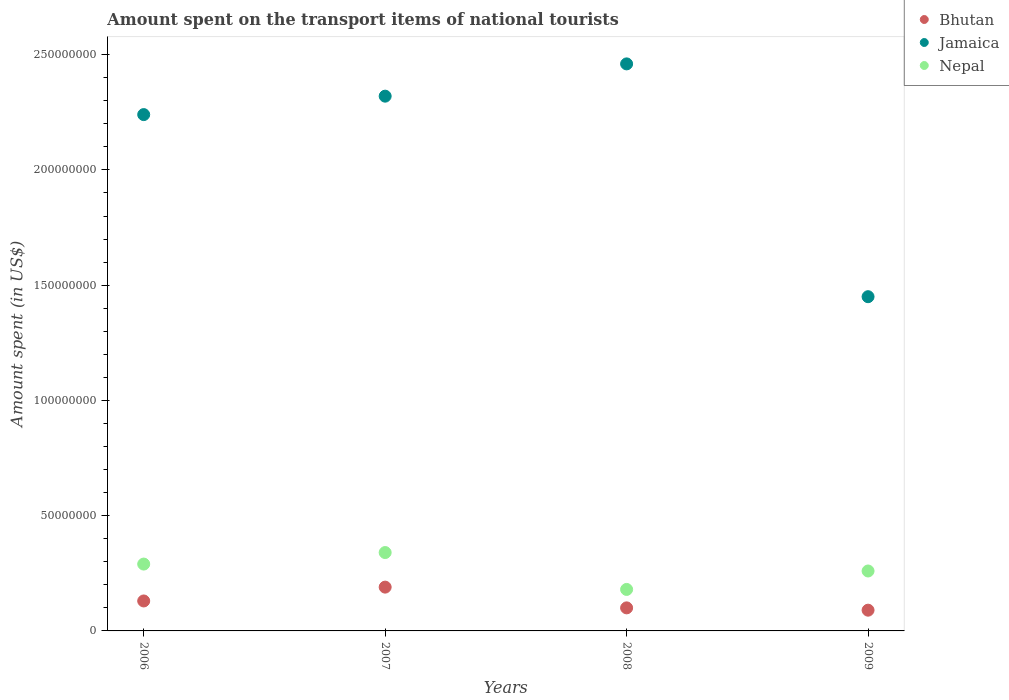How many different coloured dotlines are there?
Your answer should be compact. 3. What is the amount spent on the transport items of national tourists in Bhutan in 2006?
Provide a short and direct response. 1.30e+07. Across all years, what is the maximum amount spent on the transport items of national tourists in Nepal?
Provide a short and direct response. 3.40e+07. Across all years, what is the minimum amount spent on the transport items of national tourists in Jamaica?
Keep it short and to the point. 1.45e+08. In which year was the amount spent on the transport items of national tourists in Jamaica minimum?
Your answer should be very brief. 2009. What is the total amount spent on the transport items of national tourists in Bhutan in the graph?
Provide a succinct answer. 5.10e+07. What is the difference between the amount spent on the transport items of national tourists in Bhutan in 2007 and the amount spent on the transport items of national tourists in Jamaica in 2008?
Keep it short and to the point. -2.27e+08. What is the average amount spent on the transport items of national tourists in Nepal per year?
Ensure brevity in your answer.  2.68e+07. In the year 2007, what is the difference between the amount spent on the transport items of national tourists in Bhutan and amount spent on the transport items of national tourists in Nepal?
Give a very brief answer. -1.50e+07. Is the amount spent on the transport items of national tourists in Nepal in 2008 less than that in 2009?
Provide a short and direct response. Yes. Is the difference between the amount spent on the transport items of national tourists in Bhutan in 2008 and 2009 greater than the difference between the amount spent on the transport items of national tourists in Nepal in 2008 and 2009?
Make the answer very short. Yes. What is the difference between the highest and the second highest amount spent on the transport items of national tourists in Bhutan?
Provide a succinct answer. 6.00e+06. What is the difference between the highest and the lowest amount spent on the transport items of national tourists in Jamaica?
Your response must be concise. 1.01e+08. Does the amount spent on the transport items of national tourists in Jamaica monotonically increase over the years?
Your response must be concise. No. Is the amount spent on the transport items of national tourists in Bhutan strictly less than the amount spent on the transport items of national tourists in Jamaica over the years?
Your answer should be very brief. Yes. What is the difference between two consecutive major ticks on the Y-axis?
Ensure brevity in your answer.  5.00e+07. Are the values on the major ticks of Y-axis written in scientific E-notation?
Ensure brevity in your answer.  No. How many legend labels are there?
Make the answer very short. 3. How are the legend labels stacked?
Keep it short and to the point. Vertical. What is the title of the graph?
Your response must be concise. Amount spent on the transport items of national tourists. What is the label or title of the X-axis?
Provide a short and direct response. Years. What is the label or title of the Y-axis?
Your answer should be compact. Amount spent (in US$). What is the Amount spent (in US$) in Bhutan in 2006?
Ensure brevity in your answer.  1.30e+07. What is the Amount spent (in US$) of Jamaica in 2006?
Offer a terse response. 2.24e+08. What is the Amount spent (in US$) of Nepal in 2006?
Ensure brevity in your answer.  2.90e+07. What is the Amount spent (in US$) in Bhutan in 2007?
Your answer should be very brief. 1.90e+07. What is the Amount spent (in US$) in Jamaica in 2007?
Provide a succinct answer. 2.32e+08. What is the Amount spent (in US$) of Nepal in 2007?
Ensure brevity in your answer.  3.40e+07. What is the Amount spent (in US$) in Bhutan in 2008?
Keep it short and to the point. 1.00e+07. What is the Amount spent (in US$) in Jamaica in 2008?
Offer a very short reply. 2.46e+08. What is the Amount spent (in US$) of Nepal in 2008?
Offer a terse response. 1.80e+07. What is the Amount spent (in US$) in Bhutan in 2009?
Make the answer very short. 9.00e+06. What is the Amount spent (in US$) in Jamaica in 2009?
Keep it short and to the point. 1.45e+08. What is the Amount spent (in US$) of Nepal in 2009?
Give a very brief answer. 2.60e+07. Across all years, what is the maximum Amount spent (in US$) of Bhutan?
Your answer should be compact. 1.90e+07. Across all years, what is the maximum Amount spent (in US$) in Jamaica?
Provide a short and direct response. 2.46e+08. Across all years, what is the maximum Amount spent (in US$) of Nepal?
Give a very brief answer. 3.40e+07. Across all years, what is the minimum Amount spent (in US$) of Bhutan?
Provide a short and direct response. 9.00e+06. Across all years, what is the minimum Amount spent (in US$) of Jamaica?
Keep it short and to the point. 1.45e+08. Across all years, what is the minimum Amount spent (in US$) in Nepal?
Provide a succinct answer. 1.80e+07. What is the total Amount spent (in US$) in Bhutan in the graph?
Give a very brief answer. 5.10e+07. What is the total Amount spent (in US$) of Jamaica in the graph?
Give a very brief answer. 8.47e+08. What is the total Amount spent (in US$) of Nepal in the graph?
Offer a terse response. 1.07e+08. What is the difference between the Amount spent (in US$) in Bhutan in 2006 and that in 2007?
Offer a very short reply. -6.00e+06. What is the difference between the Amount spent (in US$) in Jamaica in 2006 and that in 2007?
Provide a succinct answer. -8.00e+06. What is the difference between the Amount spent (in US$) in Nepal in 2006 and that in 2007?
Provide a short and direct response. -5.00e+06. What is the difference between the Amount spent (in US$) in Jamaica in 2006 and that in 2008?
Your answer should be compact. -2.20e+07. What is the difference between the Amount spent (in US$) in Nepal in 2006 and that in 2008?
Offer a terse response. 1.10e+07. What is the difference between the Amount spent (in US$) in Jamaica in 2006 and that in 2009?
Your answer should be very brief. 7.90e+07. What is the difference between the Amount spent (in US$) in Bhutan in 2007 and that in 2008?
Your answer should be compact. 9.00e+06. What is the difference between the Amount spent (in US$) in Jamaica in 2007 and that in 2008?
Keep it short and to the point. -1.40e+07. What is the difference between the Amount spent (in US$) of Nepal in 2007 and that in 2008?
Offer a terse response. 1.60e+07. What is the difference between the Amount spent (in US$) of Jamaica in 2007 and that in 2009?
Your answer should be very brief. 8.70e+07. What is the difference between the Amount spent (in US$) of Jamaica in 2008 and that in 2009?
Ensure brevity in your answer.  1.01e+08. What is the difference between the Amount spent (in US$) of Nepal in 2008 and that in 2009?
Make the answer very short. -8.00e+06. What is the difference between the Amount spent (in US$) in Bhutan in 2006 and the Amount spent (in US$) in Jamaica in 2007?
Offer a terse response. -2.19e+08. What is the difference between the Amount spent (in US$) in Bhutan in 2006 and the Amount spent (in US$) in Nepal in 2007?
Provide a short and direct response. -2.10e+07. What is the difference between the Amount spent (in US$) of Jamaica in 2006 and the Amount spent (in US$) of Nepal in 2007?
Offer a terse response. 1.90e+08. What is the difference between the Amount spent (in US$) of Bhutan in 2006 and the Amount spent (in US$) of Jamaica in 2008?
Make the answer very short. -2.33e+08. What is the difference between the Amount spent (in US$) in Bhutan in 2006 and the Amount spent (in US$) in Nepal in 2008?
Your answer should be compact. -5.00e+06. What is the difference between the Amount spent (in US$) in Jamaica in 2006 and the Amount spent (in US$) in Nepal in 2008?
Ensure brevity in your answer.  2.06e+08. What is the difference between the Amount spent (in US$) in Bhutan in 2006 and the Amount spent (in US$) in Jamaica in 2009?
Give a very brief answer. -1.32e+08. What is the difference between the Amount spent (in US$) of Bhutan in 2006 and the Amount spent (in US$) of Nepal in 2009?
Give a very brief answer. -1.30e+07. What is the difference between the Amount spent (in US$) in Jamaica in 2006 and the Amount spent (in US$) in Nepal in 2009?
Your answer should be very brief. 1.98e+08. What is the difference between the Amount spent (in US$) in Bhutan in 2007 and the Amount spent (in US$) in Jamaica in 2008?
Your answer should be very brief. -2.27e+08. What is the difference between the Amount spent (in US$) of Jamaica in 2007 and the Amount spent (in US$) of Nepal in 2008?
Your answer should be compact. 2.14e+08. What is the difference between the Amount spent (in US$) of Bhutan in 2007 and the Amount spent (in US$) of Jamaica in 2009?
Your response must be concise. -1.26e+08. What is the difference between the Amount spent (in US$) in Bhutan in 2007 and the Amount spent (in US$) in Nepal in 2009?
Give a very brief answer. -7.00e+06. What is the difference between the Amount spent (in US$) in Jamaica in 2007 and the Amount spent (in US$) in Nepal in 2009?
Ensure brevity in your answer.  2.06e+08. What is the difference between the Amount spent (in US$) of Bhutan in 2008 and the Amount spent (in US$) of Jamaica in 2009?
Make the answer very short. -1.35e+08. What is the difference between the Amount spent (in US$) of Bhutan in 2008 and the Amount spent (in US$) of Nepal in 2009?
Ensure brevity in your answer.  -1.60e+07. What is the difference between the Amount spent (in US$) of Jamaica in 2008 and the Amount spent (in US$) of Nepal in 2009?
Your answer should be compact. 2.20e+08. What is the average Amount spent (in US$) of Bhutan per year?
Make the answer very short. 1.28e+07. What is the average Amount spent (in US$) in Jamaica per year?
Ensure brevity in your answer.  2.12e+08. What is the average Amount spent (in US$) in Nepal per year?
Give a very brief answer. 2.68e+07. In the year 2006, what is the difference between the Amount spent (in US$) in Bhutan and Amount spent (in US$) in Jamaica?
Ensure brevity in your answer.  -2.11e+08. In the year 2006, what is the difference between the Amount spent (in US$) of Bhutan and Amount spent (in US$) of Nepal?
Your answer should be compact. -1.60e+07. In the year 2006, what is the difference between the Amount spent (in US$) in Jamaica and Amount spent (in US$) in Nepal?
Keep it short and to the point. 1.95e+08. In the year 2007, what is the difference between the Amount spent (in US$) of Bhutan and Amount spent (in US$) of Jamaica?
Provide a short and direct response. -2.13e+08. In the year 2007, what is the difference between the Amount spent (in US$) in Bhutan and Amount spent (in US$) in Nepal?
Keep it short and to the point. -1.50e+07. In the year 2007, what is the difference between the Amount spent (in US$) in Jamaica and Amount spent (in US$) in Nepal?
Offer a terse response. 1.98e+08. In the year 2008, what is the difference between the Amount spent (in US$) in Bhutan and Amount spent (in US$) in Jamaica?
Give a very brief answer. -2.36e+08. In the year 2008, what is the difference between the Amount spent (in US$) in Bhutan and Amount spent (in US$) in Nepal?
Provide a succinct answer. -8.00e+06. In the year 2008, what is the difference between the Amount spent (in US$) in Jamaica and Amount spent (in US$) in Nepal?
Make the answer very short. 2.28e+08. In the year 2009, what is the difference between the Amount spent (in US$) of Bhutan and Amount spent (in US$) of Jamaica?
Give a very brief answer. -1.36e+08. In the year 2009, what is the difference between the Amount spent (in US$) of Bhutan and Amount spent (in US$) of Nepal?
Offer a very short reply. -1.70e+07. In the year 2009, what is the difference between the Amount spent (in US$) in Jamaica and Amount spent (in US$) in Nepal?
Provide a succinct answer. 1.19e+08. What is the ratio of the Amount spent (in US$) of Bhutan in 2006 to that in 2007?
Provide a succinct answer. 0.68. What is the ratio of the Amount spent (in US$) of Jamaica in 2006 to that in 2007?
Provide a short and direct response. 0.97. What is the ratio of the Amount spent (in US$) of Nepal in 2006 to that in 2007?
Your answer should be very brief. 0.85. What is the ratio of the Amount spent (in US$) of Jamaica in 2006 to that in 2008?
Offer a terse response. 0.91. What is the ratio of the Amount spent (in US$) in Nepal in 2006 to that in 2008?
Provide a short and direct response. 1.61. What is the ratio of the Amount spent (in US$) in Bhutan in 2006 to that in 2009?
Make the answer very short. 1.44. What is the ratio of the Amount spent (in US$) in Jamaica in 2006 to that in 2009?
Give a very brief answer. 1.54. What is the ratio of the Amount spent (in US$) in Nepal in 2006 to that in 2009?
Offer a terse response. 1.12. What is the ratio of the Amount spent (in US$) of Bhutan in 2007 to that in 2008?
Give a very brief answer. 1.9. What is the ratio of the Amount spent (in US$) of Jamaica in 2007 to that in 2008?
Your answer should be very brief. 0.94. What is the ratio of the Amount spent (in US$) of Nepal in 2007 to that in 2008?
Make the answer very short. 1.89. What is the ratio of the Amount spent (in US$) of Bhutan in 2007 to that in 2009?
Your answer should be compact. 2.11. What is the ratio of the Amount spent (in US$) in Jamaica in 2007 to that in 2009?
Your answer should be compact. 1.6. What is the ratio of the Amount spent (in US$) in Nepal in 2007 to that in 2009?
Offer a terse response. 1.31. What is the ratio of the Amount spent (in US$) of Bhutan in 2008 to that in 2009?
Your answer should be very brief. 1.11. What is the ratio of the Amount spent (in US$) of Jamaica in 2008 to that in 2009?
Provide a short and direct response. 1.7. What is the ratio of the Amount spent (in US$) of Nepal in 2008 to that in 2009?
Keep it short and to the point. 0.69. What is the difference between the highest and the second highest Amount spent (in US$) of Bhutan?
Make the answer very short. 6.00e+06. What is the difference between the highest and the second highest Amount spent (in US$) of Jamaica?
Keep it short and to the point. 1.40e+07. What is the difference between the highest and the lowest Amount spent (in US$) of Bhutan?
Give a very brief answer. 1.00e+07. What is the difference between the highest and the lowest Amount spent (in US$) in Jamaica?
Your response must be concise. 1.01e+08. What is the difference between the highest and the lowest Amount spent (in US$) of Nepal?
Ensure brevity in your answer.  1.60e+07. 